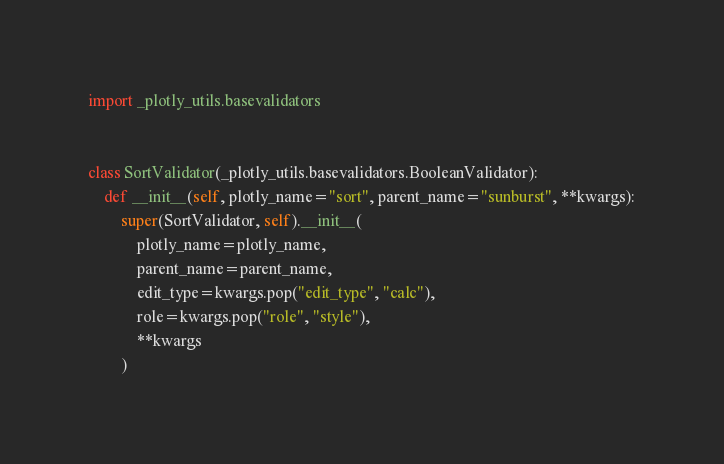<code> <loc_0><loc_0><loc_500><loc_500><_Python_>import _plotly_utils.basevalidators


class SortValidator(_plotly_utils.basevalidators.BooleanValidator):
    def __init__(self, plotly_name="sort", parent_name="sunburst", **kwargs):
        super(SortValidator, self).__init__(
            plotly_name=plotly_name,
            parent_name=parent_name,
            edit_type=kwargs.pop("edit_type", "calc"),
            role=kwargs.pop("role", "style"),
            **kwargs
        )
</code> 